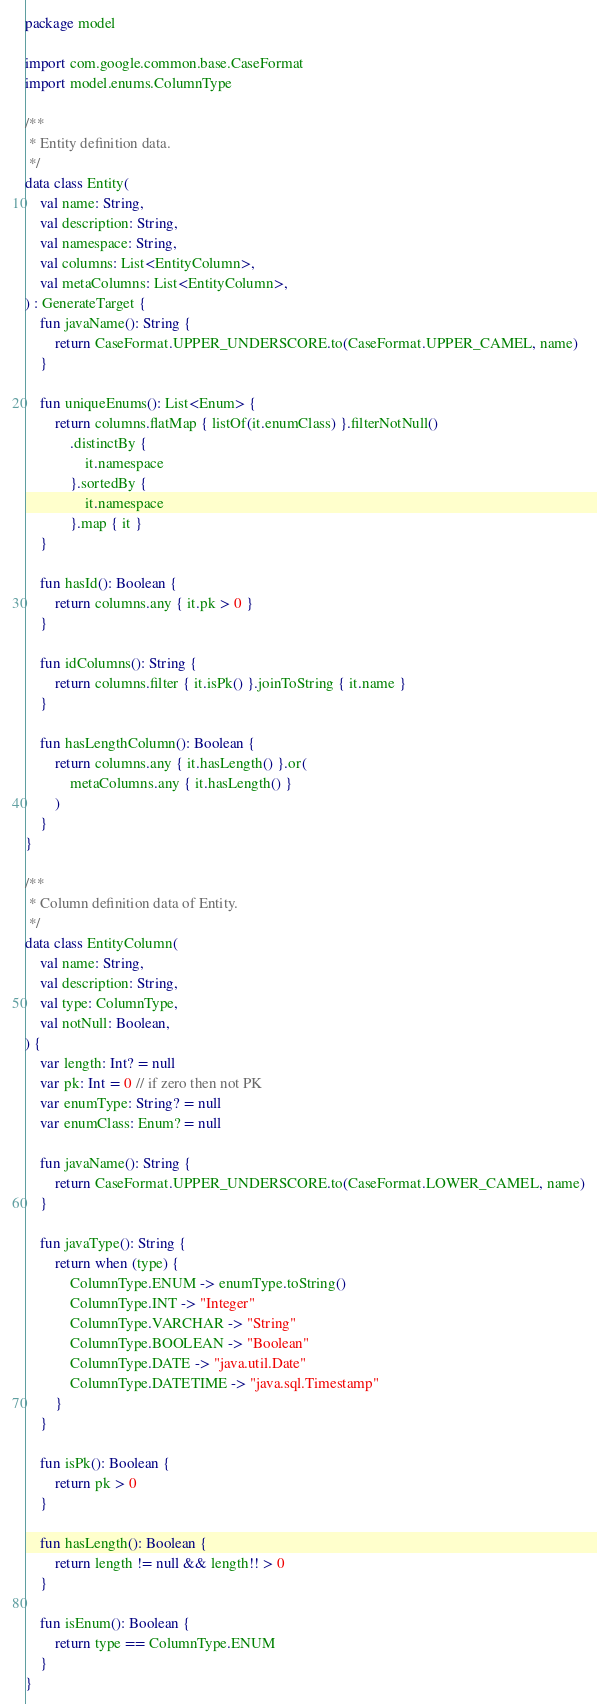<code> <loc_0><loc_0><loc_500><loc_500><_Kotlin_>package model

import com.google.common.base.CaseFormat
import model.enums.ColumnType

/**
 * Entity definition data.
 */
data class Entity(
    val name: String,
    val description: String,
    val namespace: String,
    val columns: List<EntityColumn>,
    val metaColumns: List<EntityColumn>,
) : GenerateTarget {
    fun javaName(): String {
        return CaseFormat.UPPER_UNDERSCORE.to(CaseFormat.UPPER_CAMEL, name)
    }

    fun uniqueEnums(): List<Enum> {
        return columns.flatMap { listOf(it.enumClass) }.filterNotNull()
            .distinctBy {
                it.namespace
            }.sortedBy {
                it.namespace
            }.map { it }
    }

    fun hasId(): Boolean {
        return columns.any { it.pk > 0 }
    }

    fun idColumns(): String {
        return columns.filter { it.isPk() }.joinToString { it.name }
    }

    fun hasLengthColumn(): Boolean {
        return columns.any { it.hasLength() }.or(
            metaColumns.any { it.hasLength() }
        )
    }
}

/**
 * Column definition data of Entity.
 */
data class EntityColumn(
    val name: String,
    val description: String,
    val type: ColumnType,
    val notNull: Boolean,
) {
    var length: Int? = null
    var pk: Int = 0 // if zero then not PK
    var enumType: String? = null
    var enumClass: Enum? = null

    fun javaName(): String {
        return CaseFormat.UPPER_UNDERSCORE.to(CaseFormat.LOWER_CAMEL, name)
    }

    fun javaType(): String {
        return when (type) {
            ColumnType.ENUM -> enumType.toString()
            ColumnType.INT -> "Integer"
            ColumnType.VARCHAR -> "String"
            ColumnType.BOOLEAN -> "Boolean"
            ColumnType.DATE -> "java.util.Date"
            ColumnType.DATETIME -> "java.sql.Timestamp"
        }
    }

    fun isPk(): Boolean {
        return pk > 0
    }

    fun hasLength(): Boolean {
        return length != null && length!! > 0
    }

    fun isEnum(): Boolean {
        return type == ColumnType.ENUM
    }
}
</code> 